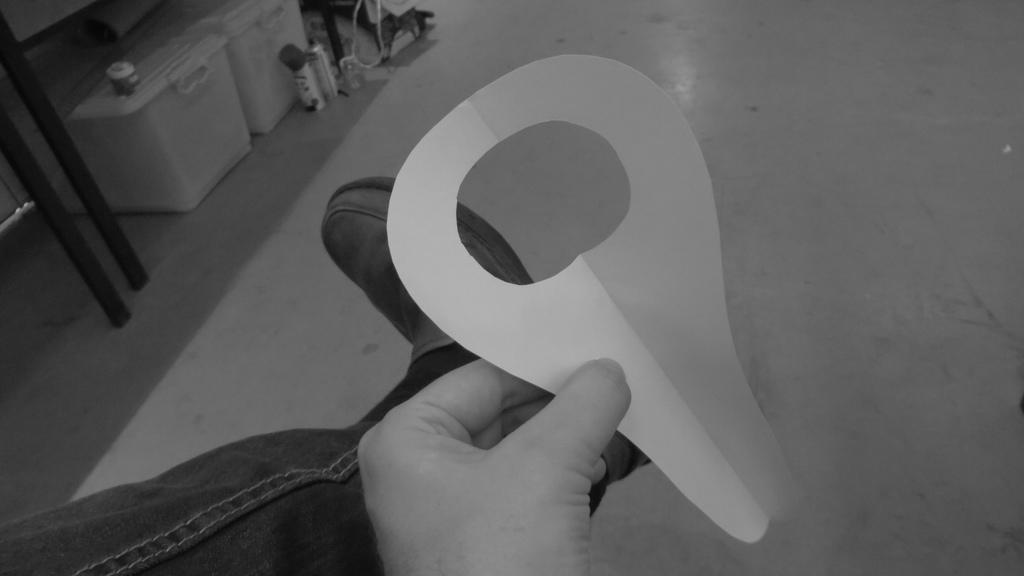What is the person in the image doing? The person is holding a piece of paper. What objects are on the floor in the image? There are boxes and spray bottles on the floor. What type of music is the band playing in the image? There is no band present in the image, so it's not possible to determine what type of music they might be playing. 